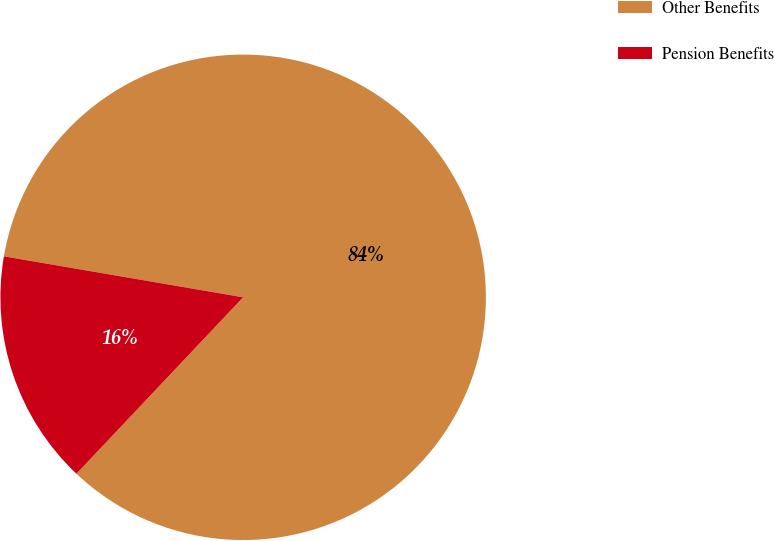Convert chart to OTSL. <chart><loc_0><loc_0><loc_500><loc_500><pie_chart><fcel>Other Benefits<fcel>Pension Benefits<nl><fcel>84.35%<fcel>15.65%<nl></chart> 